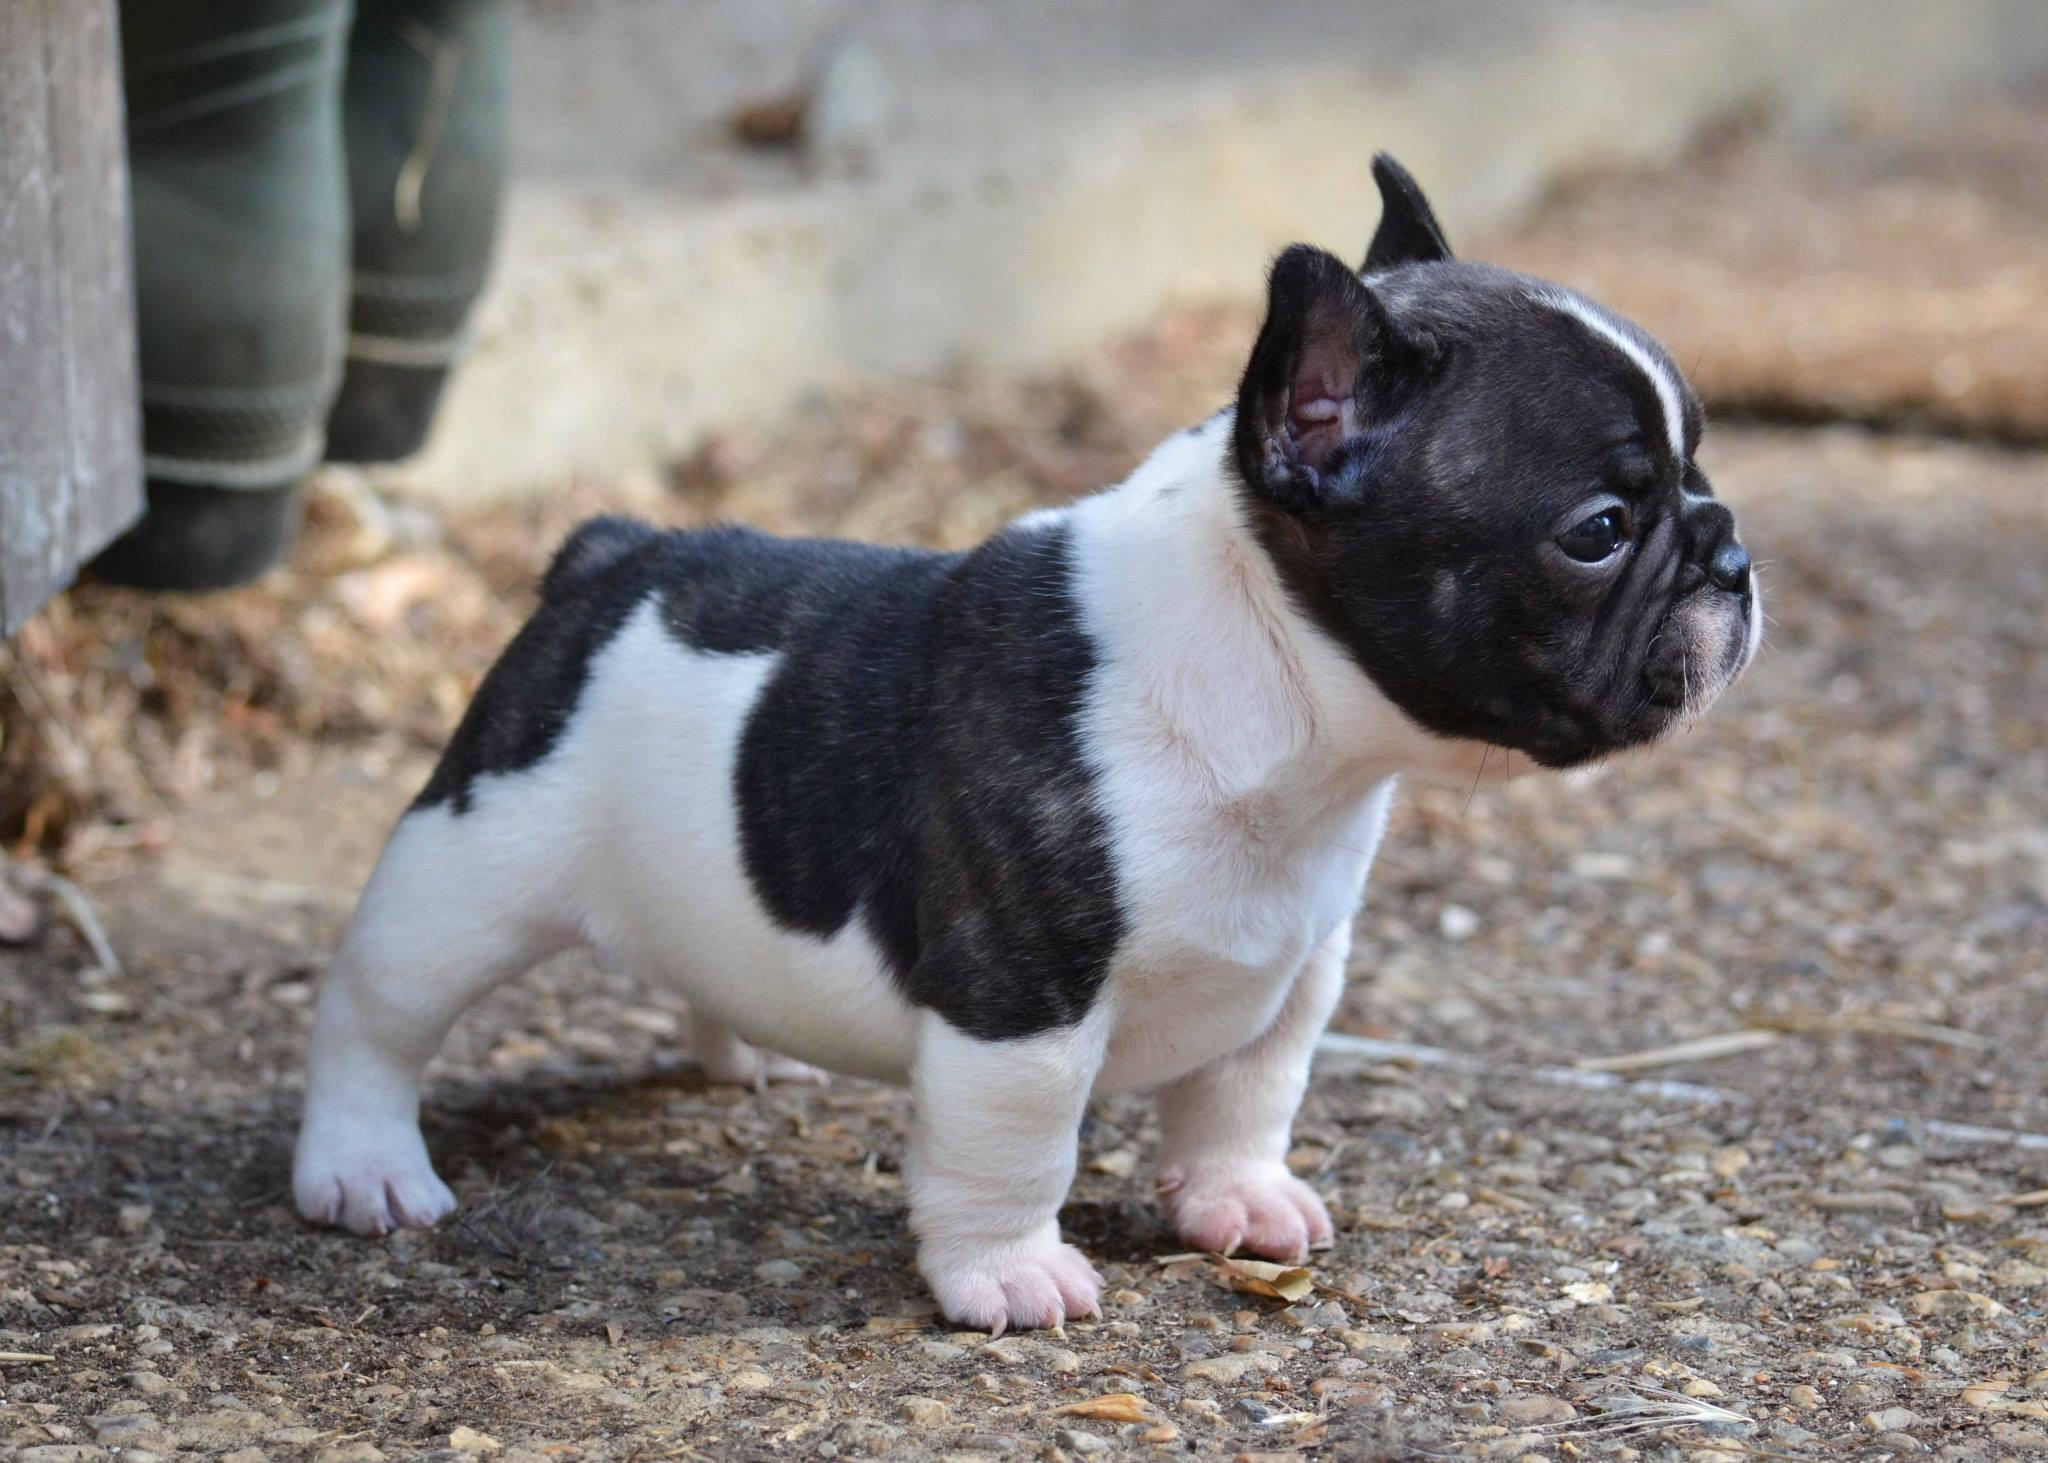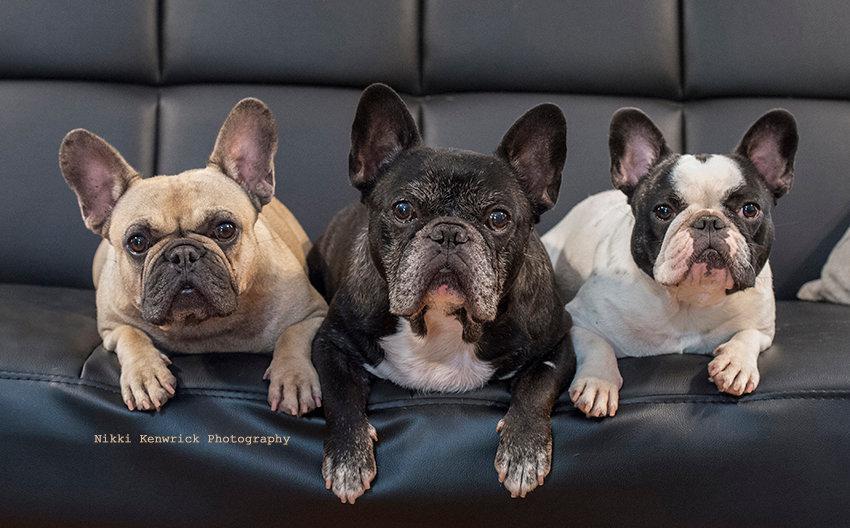The first image is the image on the left, the second image is the image on the right. Assess this claim about the two images: "There is exactly one dog in one of the images.". Correct or not? Answer yes or no. Yes. 